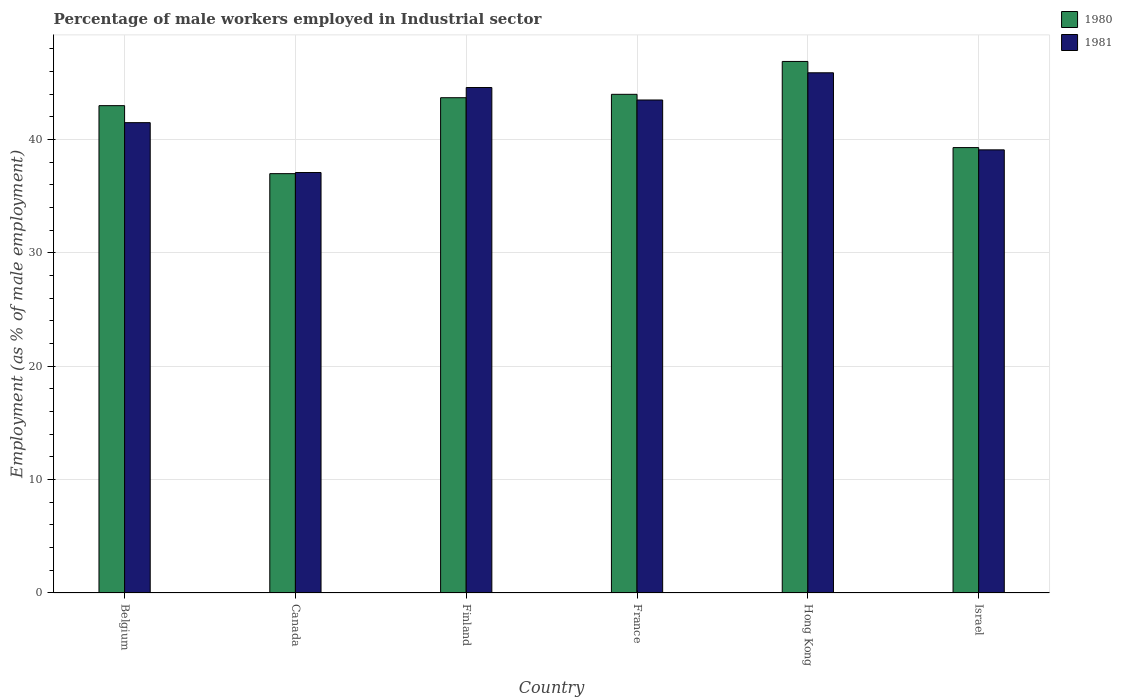How many different coloured bars are there?
Your response must be concise. 2. Are the number of bars per tick equal to the number of legend labels?
Your response must be concise. Yes. Are the number of bars on each tick of the X-axis equal?
Your answer should be compact. Yes. How many bars are there on the 5th tick from the right?
Give a very brief answer. 2. What is the label of the 2nd group of bars from the left?
Make the answer very short. Canada. In how many cases, is the number of bars for a given country not equal to the number of legend labels?
Your answer should be compact. 0. What is the percentage of male workers employed in Industrial sector in 1981 in Belgium?
Make the answer very short. 41.5. Across all countries, what is the maximum percentage of male workers employed in Industrial sector in 1981?
Your answer should be very brief. 45.9. Across all countries, what is the minimum percentage of male workers employed in Industrial sector in 1981?
Make the answer very short. 37.1. In which country was the percentage of male workers employed in Industrial sector in 1980 maximum?
Keep it short and to the point. Hong Kong. In which country was the percentage of male workers employed in Industrial sector in 1980 minimum?
Your answer should be compact. Canada. What is the total percentage of male workers employed in Industrial sector in 1980 in the graph?
Offer a terse response. 253.9. What is the difference between the percentage of male workers employed in Industrial sector in 1981 in France and the percentage of male workers employed in Industrial sector in 1980 in Israel?
Give a very brief answer. 4.2. What is the average percentage of male workers employed in Industrial sector in 1981 per country?
Your answer should be very brief. 41.95. What is the difference between the percentage of male workers employed in Industrial sector of/in 1980 and percentage of male workers employed in Industrial sector of/in 1981 in Finland?
Your response must be concise. -0.9. What is the ratio of the percentage of male workers employed in Industrial sector in 1980 in Belgium to that in Canada?
Your answer should be compact. 1.16. Is the percentage of male workers employed in Industrial sector in 1980 in Belgium less than that in Canada?
Provide a short and direct response. No. What is the difference between the highest and the second highest percentage of male workers employed in Industrial sector in 1981?
Make the answer very short. -1.1. What is the difference between the highest and the lowest percentage of male workers employed in Industrial sector in 1980?
Ensure brevity in your answer.  9.9. Is the sum of the percentage of male workers employed in Industrial sector in 1981 in France and Israel greater than the maximum percentage of male workers employed in Industrial sector in 1980 across all countries?
Keep it short and to the point. Yes. Are all the bars in the graph horizontal?
Your answer should be compact. No. How many countries are there in the graph?
Offer a terse response. 6. Are the values on the major ticks of Y-axis written in scientific E-notation?
Your answer should be compact. No. Does the graph contain grids?
Provide a short and direct response. Yes. Where does the legend appear in the graph?
Keep it short and to the point. Top right. How many legend labels are there?
Make the answer very short. 2. What is the title of the graph?
Your answer should be compact. Percentage of male workers employed in Industrial sector. Does "2009" appear as one of the legend labels in the graph?
Offer a very short reply. No. What is the label or title of the Y-axis?
Your response must be concise. Employment (as % of male employment). What is the Employment (as % of male employment) of 1981 in Belgium?
Keep it short and to the point. 41.5. What is the Employment (as % of male employment) of 1980 in Canada?
Provide a short and direct response. 37. What is the Employment (as % of male employment) in 1981 in Canada?
Give a very brief answer. 37.1. What is the Employment (as % of male employment) of 1980 in Finland?
Your answer should be compact. 43.7. What is the Employment (as % of male employment) in 1981 in Finland?
Offer a terse response. 44.6. What is the Employment (as % of male employment) in 1980 in France?
Make the answer very short. 44. What is the Employment (as % of male employment) in 1981 in France?
Offer a very short reply. 43.5. What is the Employment (as % of male employment) of 1980 in Hong Kong?
Ensure brevity in your answer.  46.9. What is the Employment (as % of male employment) in 1981 in Hong Kong?
Provide a short and direct response. 45.9. What is the Employment (as % of male employment) in 1980 in Israel?
Your response must be concise. 39.3. What is the Employment (as % of male employment) of 1981 in Israel?
Your answer should be very brief. 39.1. Across all countries, what is the maximum Employment (as % of male employment) in 1980?
Your response must be concise. 46.9. Across all countries, what is the maximum Employment (as % of male employment) in 1981?
Ensure brevity in your answer.  45.9. Across all countries, what is the minimum Employment (as % of male employment) in 1981?
Your answer should be compact. 37.1. What is the total Employment (as % of male employment) in 1980 in the graph?
Give a very brief answer. 253.9. What is the total Employment (as % of male employment) in 1981 in the graph?
Offer a very short reply. 251.7. What is the difference between the Employment (as % of male employment) in 1980 in Belgium and that in Canada?
Make the answer very short. 6. What is the difference between the Employment (as % of male employment) of 1981 in Belgium and that in Canada?
Make the answer very short. 4.4. What is the difference between the Employment (as % of male employment) in 1980 in Belgium and that in Finland?
Make the answer very short. -0.7. What is the difference between the Employment (as % of male employment) of 1981 in Belgium and that in Finland?
Offer a very short reply. -3.1. What is the difference between the Employment (as % of male employment) in 1980 in Belgium and that in France?
Keep it short and to the point. -1. What is the difference between the Employment (as % of male employment) of 1981 in Belgium and that in France?
Provide a short and direct response. -2. What is the difference between the Employment (as % of male employment) in 1980 in Belgium and that in Hong Kong?
Your response must be concise. -3.9. What is the difference between the Employment (as % of male employment) in 1981 in Belgium and that in Hong Kong?
Ensure brevity in your answer.  -4.4. What is the difference between the Employment (as % of male employment) of 1980 in Belgium and that in Israel?
Make the answer very short. 3.7. What is the difference between the Employment (as % of male employment) of 1980 in Canada and that in Finland?
Provide a succinct answer. -6.7. What is the difference between the Employment (as % of male employment) of 1981 in Canada and that in Finland?
Your response must be concise. -7.5. What is the difference between the Employment (as % of male employment) of 1980 in Canada and that in France?
Your response must be concise. -7. What is the difference between the Employment (as % of male employment) of 1980 in Finland and that in France?
Provide a short and direct response. -0.3. What is the difference between the Employment (as % of male employment) of 1981 in Finland and that in France?
Your answer should be very brief. 1.1. What is the difference between the Employment (as % of male employment) in 1980 in Finland and that in Hong Kong?
Your answer should be compact. -3.2. What is the difference between the Employment (as % of male employment) in 1981 in Finland and that in Hong Kong?
Ensure brevity in your answer.  -1.3. What is the difference between the Employment (as % of male employment) in 1980 in France and that in Israel?
Offer a terse response. 4.7. What is the difference between the Employment (as % of male employment) in 1980 in Hong Kong and that in Israel?
Offer a terse response. 7.6. What is the difference between the Employment (as % of male employment) in 1981 in Hong Kong and that in Israel?
Provide a short and direct response. 6.8. What is the difference between the Employment (as % of male employment) of 1980 in Belgium and the Employment (as % of male employment) of 1981 in Canada?
Your answer should be compact. 5.9. What is the difference between the Employment (as % of male employment) in 1980 in Belgium and the Employment (as % of male employment) in 1981 in France?
Your response must be concise. -0.5. What is the difference between the Employment (as % of male employment) in 1980 in Finland and the Employment (as % of male employment) in 1981 in France?
Provide a short and direct response. 0.2. What is the difference between the Employment (as % of male employment) in 1980 in Finland and the Employment (as % of male employment) in 1981 in Hong Kong?
Offer a terse response. -2.2. What is the difference between the Employment (as % of male employment) in 1980 in France and the Employment (as % of male employment) in 1981 in Hong Kong?
Ensure brevity in your answer.  -1.9. What is the difference between the Employment (as % of male employment) of 1980 in France and the Employment (as % of male employment) of 1981 in Israel?
Ensure brevity in your answer.  4.9. What is the difference between the Employment (as % of male employment) in 1980 in Hong Kong and the Employment (as % of male employment) in 1981 in Israel?
Provide a short and direct response. 7.8. What is the average Employment (as % of male employment) in 1980 per country?
Give a very brief answer. 42.32. What is the average Employment (as % of male employment) in 1981 per country?
Your answer should be compact. 41.95. What is the difference between the Employment (as % of male employment) of 1980 and Employment (as % of male employment) of 1981 in Belgium?
Your answer should be very brief. 1.5. What is the difference between the Employment (as % of male employment) in 1980 and Employment (as % of male employment) in 1981 in France?
Make the answer very short. 0.5. What is the difference between the Employment (as % of male employment) of 1980 and Employment (as % of male employment) of 1981 in Israel?
Keep it short and to the point. 0.2. What is the ratio of the Employment (as % of male employment) in 1980 in Belgium to that in Canada?
Offer a terse response. 1.16. What is the ratio of the Employment (as % of male employment) of 1981 in Belgium to that in Canada?
Offer a very short reply. 1.12. What is the ratio of the Employment (as % of male employment) in 1981 in Belgium to that in Finland?
Give a very brief answer. 0.93. What is the ratio of the Employment (as % of male employment) in 1980 in Belgium to that in France?
Offer a very short reply. 0.98. What is the ratio of the Employment (as % of male employment) in 1981 in Belgium to that in France?
Offer a very short reply. 0.95. What is the ratio of the Employment (as % of male employment) of 1980 in Belgium to that in Hong Kong?
Your answer should be compact. 0.92. What is the ratio of the Employment (as % of male employment) in 1981 in Belgium to that in Hong Kong?
Offer a terse response. 0.9. What is the ratio of the Employment (as % of male employment) in 1980 in Belgium to that in Israel?
Offer a very short reply. 1.09. What is the ratio of the Employment (as % of male employment) in 1981 in Belgium to that in Israel?
Offer a very short reply. 1.06. What is the ratio of the Employment (as % of male employment) in 1980 in Canada to that in Finland?
Provide a short and direct response. 0.85. What is the ratio of the Employment (as % of male employment) of 1981 in Canada to that in Finland?
Provide a succinct answer. 0.83. What is the ratio of the Employment (as % of male employment) in 1980 in Canada to that in France?
Keep it short and to the point. 0.84. What is the ratio of the Employment (as % of male employment) of 1981 in Canada to that in France?
Ensure brevity in your answer.  0.85. What is the ratio of the Employment (as % of male employment) of 1980 in Canada to that in Hong Kong?
Your answer should be very brief. 0.79. What is the ratio of the Employment (as % of male employment) in 1981 in Canada to that in Hong Kong?
Your answer should be very brief. 0.81. What is the ratio of the Employment (as % of male employment) of 1980 in Canada to that in Israel?
Your answer should be very brief. 0.94. What is the ratio of the Employment (as % of male employment) of 1981 in Canada to that in Israel?
Your answer should be compact. 0.95. What is the ratio of the Employment (as % of male employment) in 1980 in Finland to that in France?
Provide a short and direct response. 0.99. What is the ratio of the Employment (as % of male employment) in 1981 in Finland to that in France?
Give a very brief answer. 1.03. What is the ratio of the Employment (as % of male employment) of 1980 in Finland to that in Hong Kong?
Your answer should be very brief. 0.93. What is the ratio of the Employment (as % of male employment) in 1981 in Finland to that in Hong Kong?
Offer a very short reply. 0.97. What is the ratio of the Employment (as % of male employment) in 1980 in Finland to that in Israel?
Provide a succinct answer. 1.11. What is the ratio of the Employment (as % of male employment) in 1981 in Finland to that in Israel?
Give a very brief answer. 1.14. What is the ratio of the Employment (as % of male employment) of 1980 in France to that in Hong Kong?
Provide a succinct answer. 0.94. What is the ratio of the Employment (as % of male employment) in 1981 in France to that in Hong Kong?
Provide a succinct answer. 0.95. What is the ratio of the Employment (as % of male employment) of 1980 in France to that in Israel?
Your response must be concise. 1.12. What is the ratio of the Employment (as % of male employment) of 1981 in France to that in Israel?
Make the answer very short. 1.11. What is the ratio of the Employment (as % of male employment) in 1980 in Hong Kong to that in Israel?
Your answer should be very brief. 1.19. What is the ratio of the Employment (as % of male employment) of 1981 in Hong Kong to that in Israel?
Your answer should be compact. 1.17. What is the difference between the highest and the second highest Employment (as % of male employment) in 1980?
Offer a very short reply. 2.9. What is the difference between the highest and the second highest Employment (as % of male employment) of 1981?
Provide a succinct answer. 1.3. What is the difference between the highest and the lowest Employment (as % of male employment) of 1981?
Make the answer very short. 8.8. 